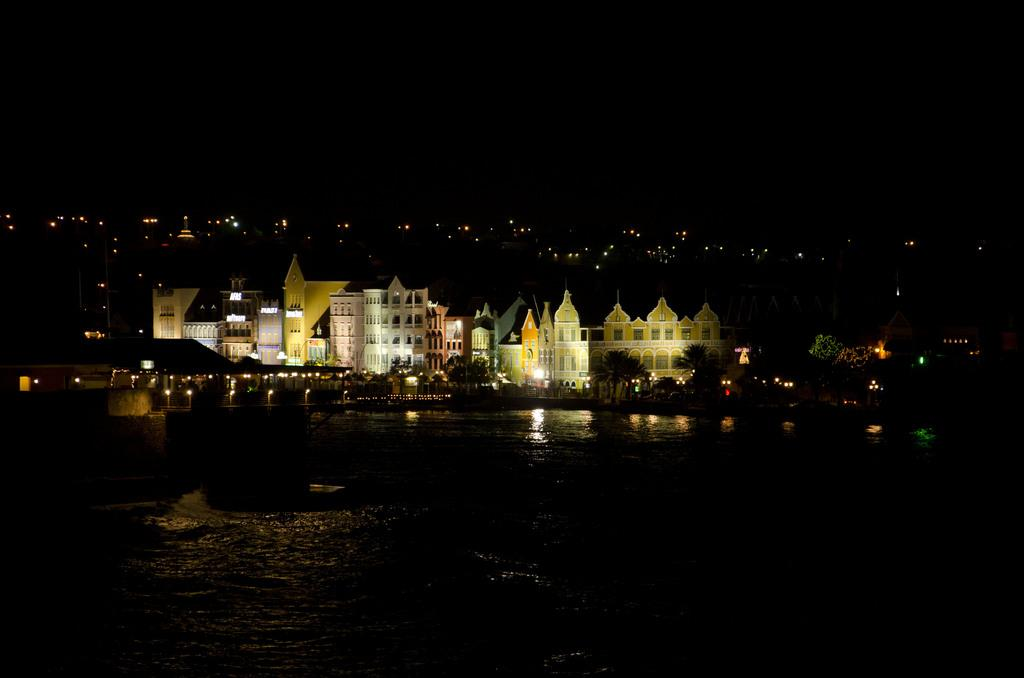What type of structures can be seen in the image? There are buildings in the image. What other natural elements are present in the image? There are trees in the image. Are there any artificial light sources visible in the image? Yes, there are lights in the image. What can be seen at the bottom of the image? There is water visible at the bottom of the image. How would you describe the lighting conditions at the top of the image? The top of the image appears to be dark. What type of pump is used to control the water flow in the image? There is no pump present in the image; it only shows buildings, trees, lights, water, and a dark top. What kind of flowers can be seen growing near the trees in the image? There are no flowers visible in the image; it only shows buildings, trees, lights, water, and a dark top. 